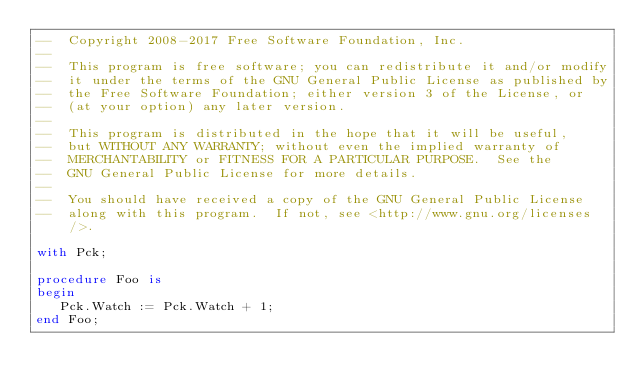Convert code to text. <code><loc_0><loc_0><loc_500><loc_500><_Ada_>--  Copyright 2008-2017 Free Software Foundation, Inc.
--
--  This program is free software; you can redistribute it and/or modify
--  it under the terms of the GNU General Public License as published by
--  the Free Software Foundation; either version 3 of the License, or
--  (at your option) any later version.
--
--  This program is distributed in the hope that it will be useful,
--  but WITHOUT ANY WARRANTY; without even the implied warranty of
--  MERCHANTABILITY or FITNESS FOR A PARTICULAR PURPOSE.  See the
--  GNU General Public License for more details.
--
--  You should have received a copy of the GNU General Public License
--  along with this program.  If not, see <http://www.gnu.org/licenses/>.

with Pck;

procedure Foo is
begin
   Pck.Watch := Pck.Watch + 1;
end Foo;
</code> 